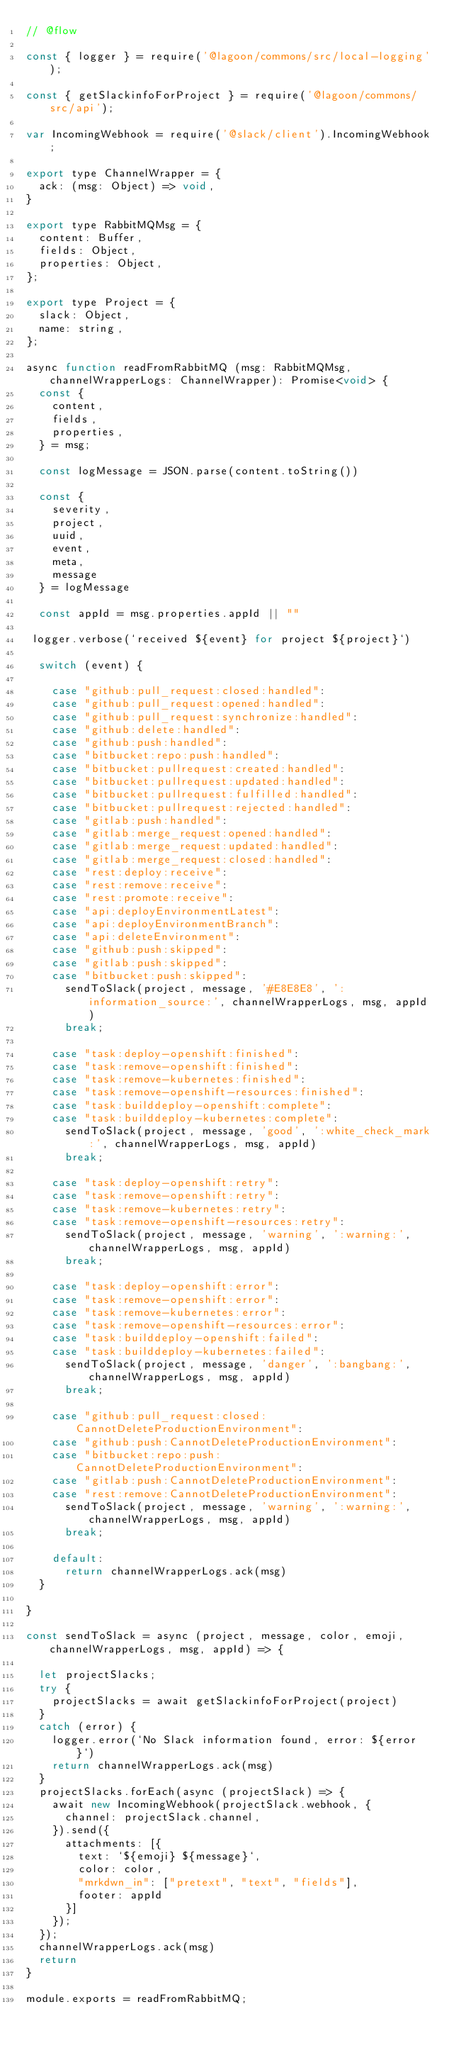<code> <loc_0><loc_0><loc_500><loc_500><_JavaScript_>// @flow

const { logger } = require('@lagoon/commons/src/local-logging');

const { getSlackinfoForProject } = require('@lagoon/commons/src/api');

var IncomingWebhook = require('@slack/client').IncomingWebhook;

export type ChannelWrapper = {
  ack: (msg: Object) => void,
}

export type RabbitMQMsg = {
  content: Buffer,
  fields: Object,
  properties: Object,
};

export type Project = {
  slack: Object,
  name: string,
};

async function readFromRabbitMQ (msg: RabbitMQMsg, channelWrapperLogs: ChannelWrapper): Promise<void> {
  const {
    content,
    fields,
    properties,
  } = msg;

  const logMessage = JSON.parse(content.toString())

  const {
    severity,
    project,
    uuid,
    event,
    meta,
    message
  } = logMessage

  const appId = msg.properties.appId || ""

 logger.verbose(`received ${event} for project ${project}`)

  switch (event) {

    case "github:pull_request:closed:handled":
    case "github:pull_request:opened:handled":
    case "github:pull_request:synchronize:handled":
    case "github:delete:handled":
    case "github:push:handled":
    case "bitbucket:repo:push:handled":
    case "bitbucket:pullrequest:created:handled":
    case "bitbucket:pullrequest:updated:handled":
    case "bitbucket:pullrequest:fulfilled:handled":
    case "bitbucket:pullrequest:rejected:handled":
    case "gitlab:push:handled":
    case "gitlab:merge_request:opened:handled":
    case "gitlab:merge_request:updated:handled":
    case "gitlab:merge_request:closed:handled":
    case "rest:deploy:receive":
    case "rest:remove:receive":
    case "rest:promote:receive":
    case "api:deployEnvironmentLatest":
    case "api:deployEnvironmentBranch":
    case "api:deleteEnvironment":
    case "github:push:skipped":
    case "gitlab:push:skipped":
    case "bitbucket:push:skipped":
      sendToSlack(project, message, '#E8E8E8', ':information_source:', channelWrapperLogs, msg, appId)
      break;

    case "task:deploy-openshift:finished":
    case "task:remove-openshift:finished":
    case "task:remove-kubernetes:finished":
    case "task:remove-openshift-resources:finished":
    case "task:builddeploy-openshift:complete":
    case "task:builddeploy-kubernetes:complete":
      sendToSlack(project, message, 'good', ':white_check_mark:', channelWrapperLogs, msg, appId)
      break;

    case "task:deploy-openshift:retry":
    case "task:remove-openshift:retry":
    case "task:remove-kubernetes:retry":
    case "task:remove-openshift-resources:retry":
      sendToSlack(project, message, 'warning', ':warning:', channelWrapperLogs, msg, appId)
      break;

    case "task:deploy-openshift:error":
    case "task:remove-openshift:error":
    case "task:remove-kubernetes:error":
    case "task:remove-openshift-resources:error":
    case "task:builddeploy-openshift:failed":
    case "task:builddeploy-kubernetes:failed":
      sendToSlack(project, message, 'danger', ':bangbang:', channelWrapperLogs, msg, appId)
      break;

    case "github:pull_request:closed:CannotDeleteProductionEnvironment":
    case "github:push:CannotDeleteProductionEnvironment":
    case "bitbucket:repo:push:CannotDeleteProductionEnvironment":
    case "gitlab:push:CannotDeleteProductionEnvironment":
    case "rest:remove:CannotDeleteProductionEnvironment":
      sendToSlack(project, message, 'warning', ':warning:', channelWrapperLogs, msg, appId)
      break;

    default:
      return channelWrapperLogs.ack(msg)
  }

}

const sendToSlack = async (project, message, color, emoji, channelWrapperLogs, msg, appId) => {

  let projectSlacks;
  try {
    projectSlacks = await getSlackinfoForProject(project)
  }
  catch (error) {
    logger.error(`No Slack information found, error: ${error}`)
    return channelWrapperLogs.ack(msg)
  }
  projectSlacks.forEach(async (projectSlack) => {
    await new IncomingWebhook(projectSlack.webhook, {
      channel: projectSlack.channel,
    }).send({
      attachments: [{
        text: `${emoji} ${message}`,
        color: color,
        "mrkdwn_in": ["pretext", "text", "fields"],
        footer: appId
      }]
    });
  });
  channelWrapperLogs.ack(msg)
  return
}

module.exports = readFromRabbitMQ;
</code> 